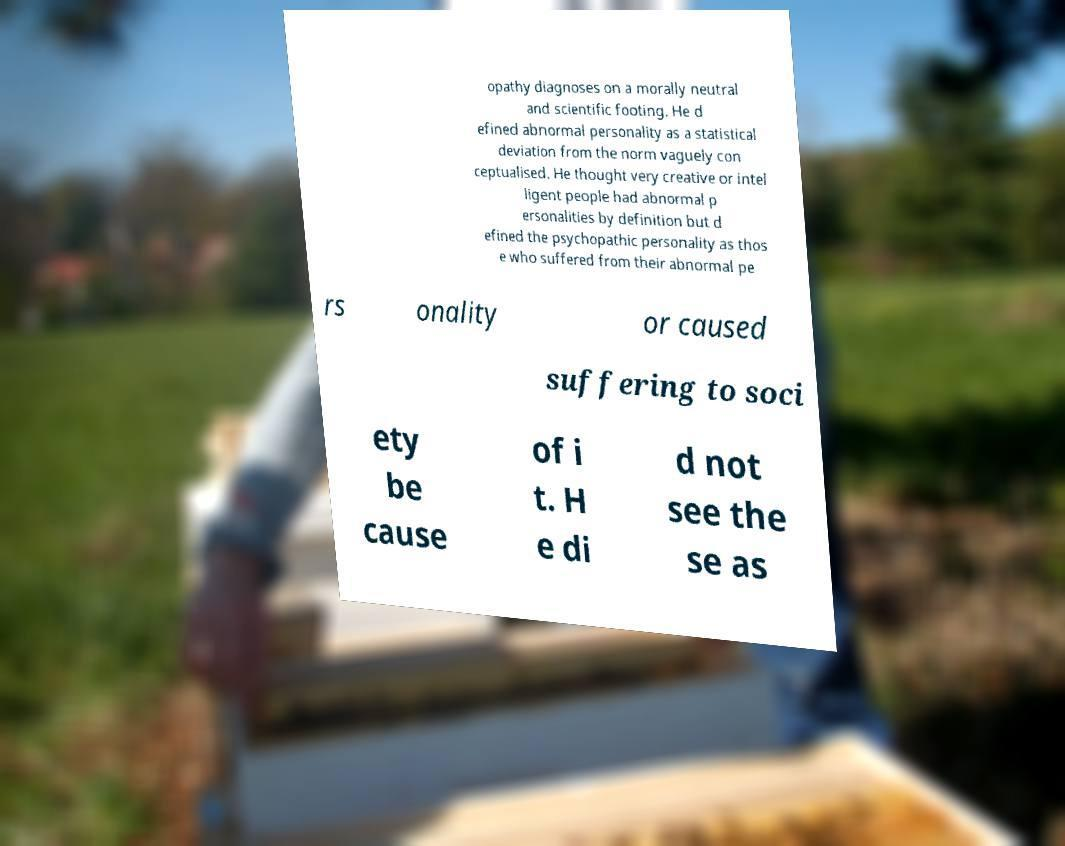There's text embedded in this image that I need extracted. Can you transcribe it verbatim? opathy diagnoses on a morally neutral and scientific footing. He d efined abnormal personality as a statistical deviation from the norm vaguely con ceptualised. He thought very creative or intel ligent people had abnormal p ersonalities by definition but d efined the psychopathic personality as thos e who suffered from their abnormal pe rs onality or caused suffering to soci ety be cause of i t. H e di d not see the se as 